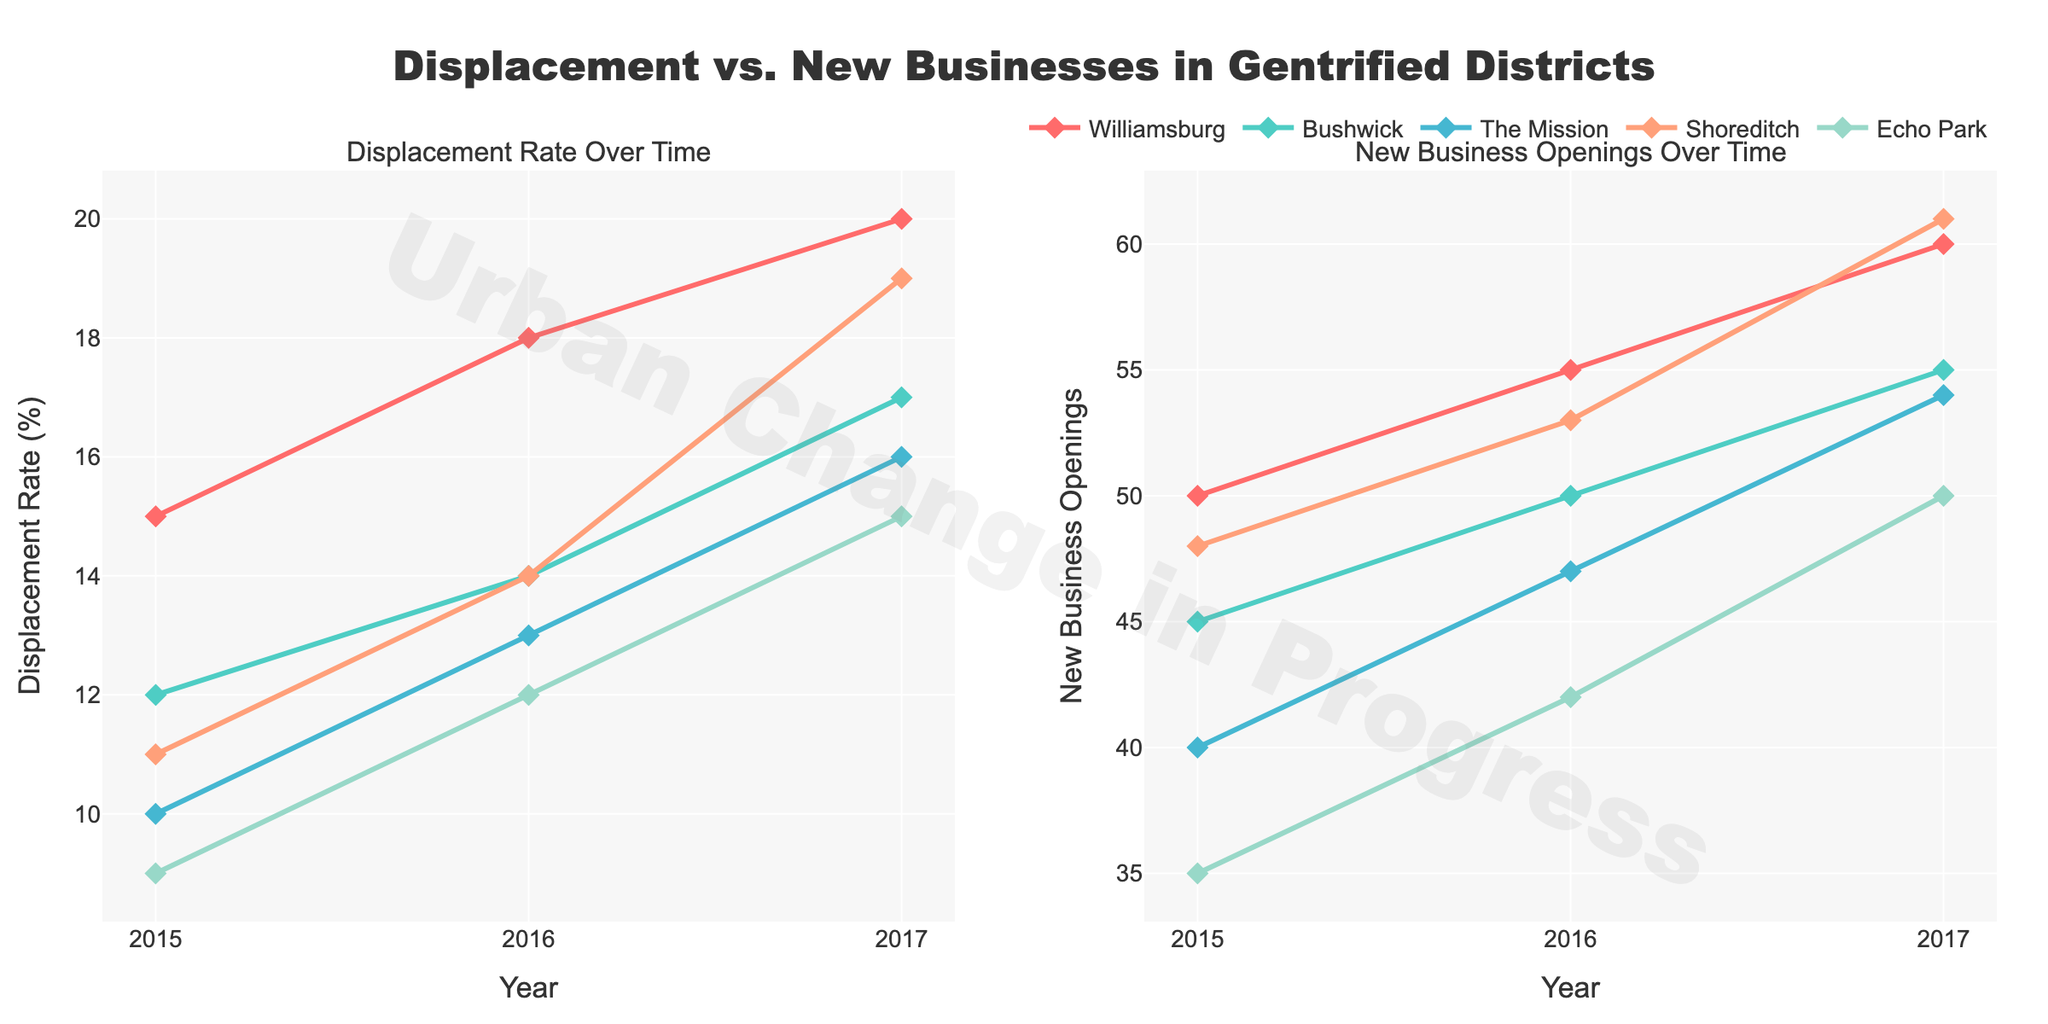What is the title of the plot? The overall title is displayed at the top center of the plot.
Answer: Displacement vs. New Businesses in Gentrified Districts How many neighborhoods are represented in the plots? Count the number of unique neighborhood names in the legend and line markers.
Answer: 5 Which neighborhood had the highest displacement rate in 2017? Observe the 2017 data points on the left subplot and find the neighborhood with the highest value on the y-axis.
Answer: Shoreditch What is the trend in displacement rates for Williamsburg from 2015 to 2017? Look at the line and markers for Williamsburg on the left subplot and observe the direction of the graph from 2015 to 2017.
Answer: Increasing How many new business openings were there in Echo Park in 2016? Find the data point for 2016 for Echo Park on the right subplot and read the y-axis value.
Answer: 42 Which neighborhood had the lowest number of new business openings in 2015? Observe the 2015 data points on the right subplot and find the neighborhood with the lowest value on the y-axis.
Answer: Echo Park How did the number of new business openings change for Bushwick from 2015 to 2017? Look at the line and markers for Bushwick on the right subplot and describe the change from 2015 to 2017.
Answer: Increased Compare the displacement rate for Bushwick and The Mission in 2016. Which was higher? Observe the data points for 2016 for both neighborhoods on the left subplot and compare their y-axis values.
Answer: Bushwick What is the average displacement rate of The Mission across the years presented? Sum the displacement rates of The Mission for 2015, 2016, and 2017, then divide by the number of years. (10+13+16)/3 = 13
Answer: 13 